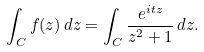<formula> <loc_0><loc_0><loc_500><loc_500>\int _ { C } { f ( z ) } \, d z = \int _ { C } { \frac { e ^ { i t z } } { z ^ { 2 } + 1 } } \, d z .</formula> 